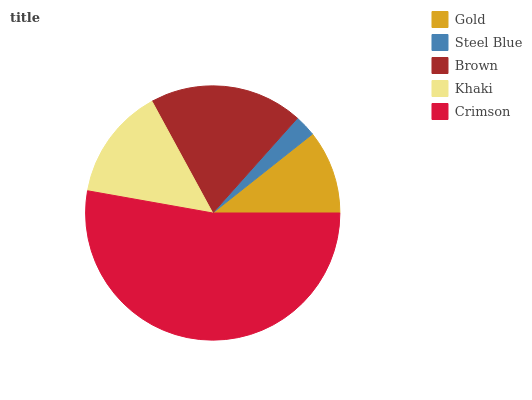Is Steel Blue the minimum?
Answer yes or no. Yes. Is Crimson the maximum?
Answer yes or no. Yes. Is Brown the minimum?
Answer yes or no. No. Is Brown the maximum?
Answer yes or no. No. Is Brown greater than Steel Blue?
Answer yes or no. Yes. Is Steel Blue less than Brown?
Answer yes or no. Yes. Is Steel Blue greater than Brown?
Answer yes or no. No. Is Brown less than Steel Blue?
Answer yes or no. No. Is Khaki the high median?
Answer yes or no. Yes. Is Khaki the low median?
Answer yes or no. Yes. Is Brown the high median?
Answer yes or no. No. Is Brown the low median?
Answer yes or no. No. 